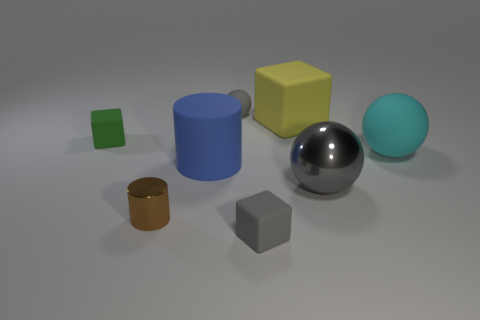Add 2 yellow rubber things. How many objects exist? 10 Subtract all tiny cubes. How many cubes are left? 1 Subtract all cyan spheres. How many spheres are left? 2 Add 1 matte balls. How many matte balls exist? 3 Subtract 1 gray balls. How many objects are left? 7 Subtract all cubes. How many objects are left? 5 Subtract 2 spheres. How many spheres are left? 1 Subtract all red cubes. Subtract all yellow balls. How many cubes are left? 3 Subtract all blue cubes. How many gray cylinders are left? 0 Subtract all cyan matte objects. Subtract all gray balls. How many objects are left? 5 